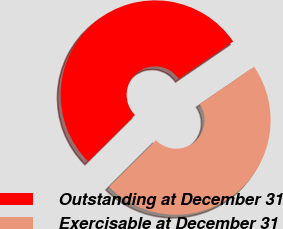Convert chart. <chart><loc_0><loc_0><loc_500><loc_500><pie_chart><fcel>Outstanding at December 31<fcel>Exercisable at December 31<nl><fcel>52.9%<fcel>47.1%<nl></chart> 